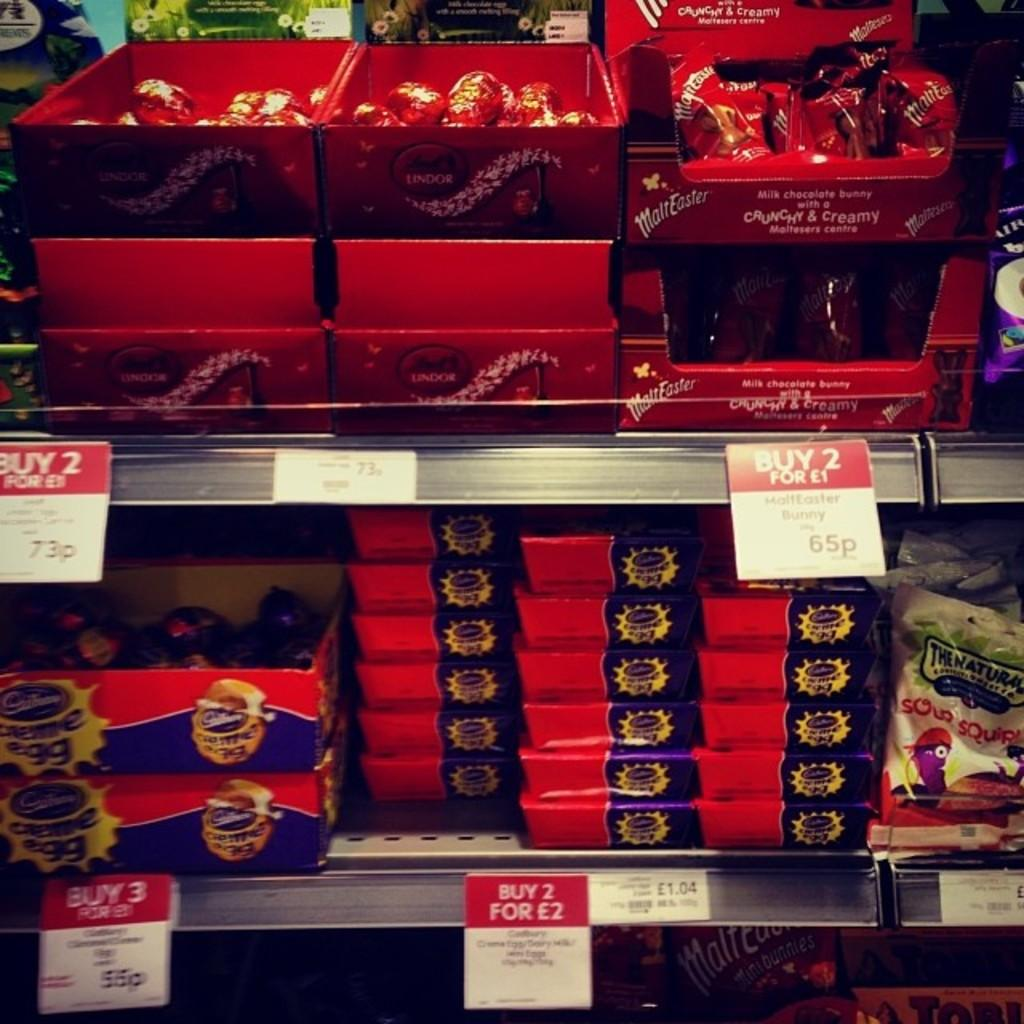What type of objects are in the image with text and images on them? There are boxes with text and images in the image. What other items in the image have text on them? There are papers with text in the image. Where are the boxes located in the image? The boxes are on shelves in the image. How many police officers are visible in the image? There are no police officers present in the image. What trick can be performed with the boxes in the image? There is no trick being performed with the boxes in the image; they are simply sitting on shelves. 